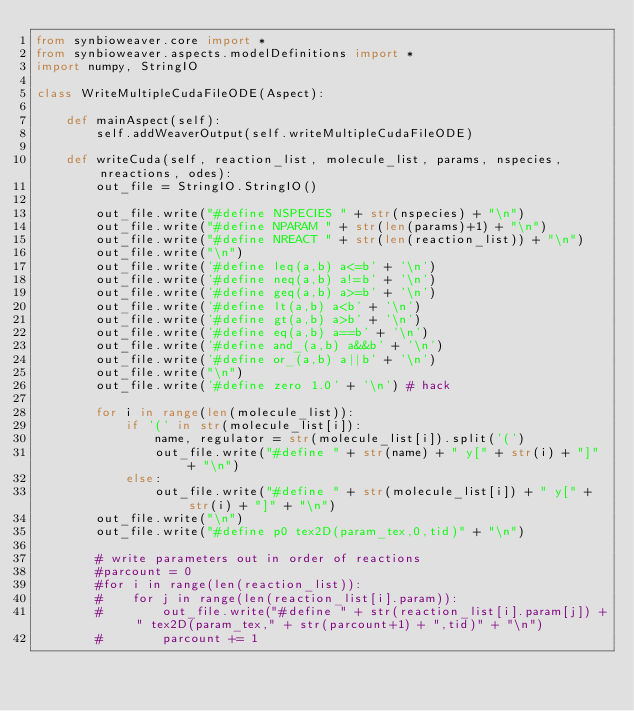Convert code to text. <code><loc_0><loc_0><loc_500><loc_500><_Python_>from synbioweaver.core import *
from synbioweaver.aspects.modelDefinitions import *
import numpy, StringIO

class WriteMultipleCudaFileODE(Aspect):

    def mainAspect(self):
        self.addWeaverOutput(self.writeMultipleCudaFileODE)

    def writeCuda(self, reaction_list, molecule_list, params, nspecies, nreactions, odes):
        out_file = StringIO.StringIO()

        out_file.write("#define NSPECIES " + str(nspecies) + "\n")
        out_file.write("#define NPARAM " + str(len(params)+1) + "\n")
        out_file.write("#define NREACT " + str(len(reaction_list)) + "\n")
        out_file.write("\n")
        out_file.write('#define leq(a,b) a<=b' + '\n')
        out_file.write('#define neq(a,b) a!=b' + '\n')
        out_file.write('#define geq(a,b) a>=b' + '\n')
        out_file.write('#define lt(a,b) a<b' + '\n')
        out_file.write('#define gt(a,b) a>b' + '\n')
        out_file.write('#define eq(a,b) a==b' + '\n')
        out_file.write('#define and_(a,b) a&&b' + '\n')
        out_file.write('#define or_(a,b) a||b' + '\n')
        out_file.write("\n")
        out_file.write('#define zero 1.0' + '\n') # hack
        
        for i in range(len(molecule_list)):
            if '(' in str(molecule_list[i]):
                name, regulator = str(molecule_list[i]).split('(')
                out_file.write("#define " + str(name) + " y[" + str(i) + "]" + "\n")
            else:
                out_file.write("#define " + str(molecule_list[i]) + " y[" + str(i) + "]" + "\n")
        out_file.write("\n")
        out_file.write("#define p0 tex2D(param_tex,0,tid)" + "\n")

        # write parameters out in order of reactions
        #parcount = 0
        #for i in range(len(reaction_list)):
        #    for j in range(len(reaction_list[i].param)):
        #        out_file.write("#define " + str(reaction_list[i].param[j]) + " tex2D(param_tex," + str(parcount+1) + ",tid)" + "\n")
        #        parcount += 1
</code> 